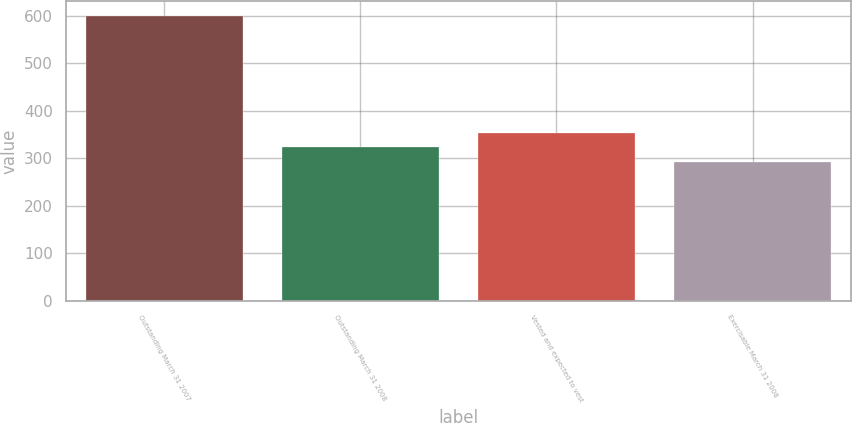<chart> <loc_0><loc_0><loc_500><loc_500><bar_chart><fcel>Outstanding March 31 2007<fcel>Outstanding March 31 2008<fcel>Vested and expected to vest<fcel>Exercisable March 31 2008<nl><fcel>601<fcel>322.9<fcel>353.8<fcel>292<nl></chart> 